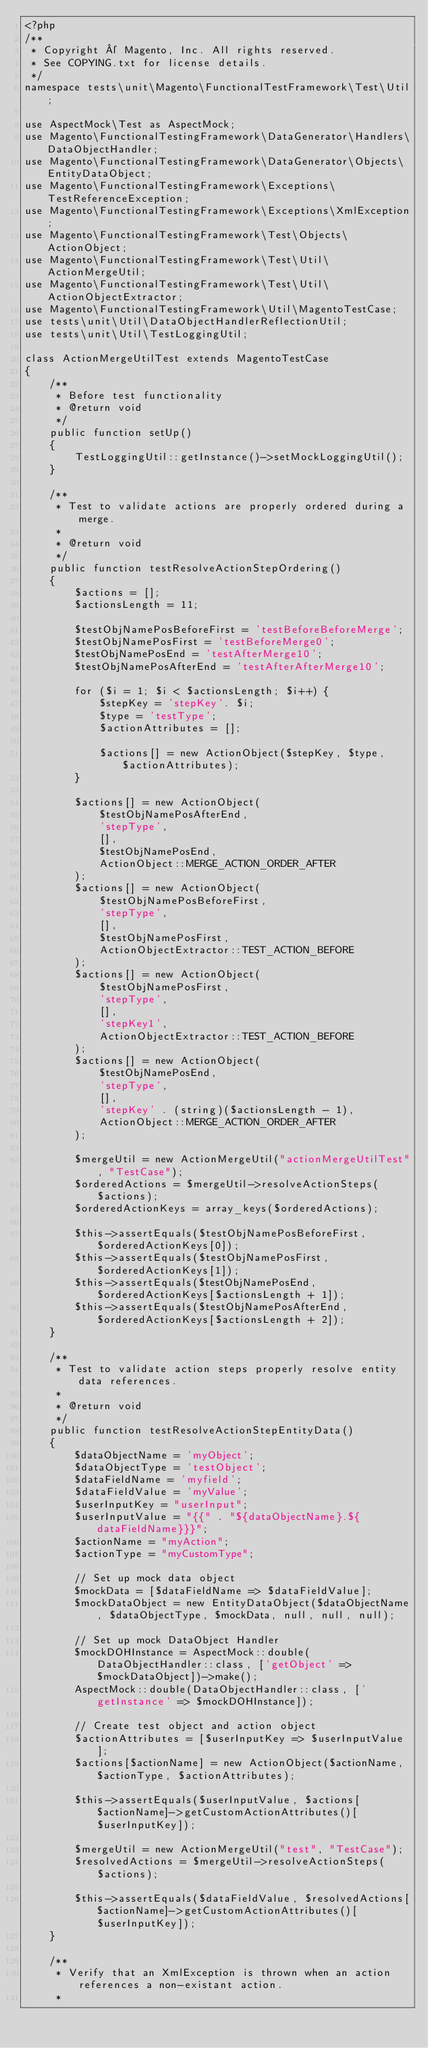<code> <loc_0><loc_0><loc_500><loc_500><_PHP_><?php
/**
 * Copyright © Magento, Inc. All rights reserved.
 * See COPYING.txt for license details.
 */
namespace tests\unit\Magento\FunctionalTestFramework\Test\Util;

use AspectMock\Test as AspectMock;
use Magento\FunctionalTestingFramework\DataGenerator\Handlers\DataObjectHandler;
use Magento\FunctionalTestingFramework\DataGenerator\Objects\EntityDataObject;
use Magento\FunctionalTestingFramework\Exceptions\TestReferenceException;
use Magento\FunctionalTestingFramework\Exceptions\XmlException;
use Magento\FunctionalTestingFramework\Test\Objects\ActionObject;
use Magento\FunctionalTestingFramework\Test\Util\ActionMergeUtil;
use Magento\FunctionalTestingFramework\Test\Util\ActionObjectExtractor;
use Magento\FunctionalTestingFramework\Util\MagentoTestCase;
use tests\unit\Util\DataObjectHandlerReflectionUtil;
use tests\unit\Util\TestLoggingUtil;

class ActionMergeUtilTest extends MagentoTestCase
{
    /**
     * Before test functionality
     * @return void
     */
    public function setUp()
    {
        TestLoggingUtil::getInstance()->setMockLoggingUtil();
    }

    /**
     * Test to validate actions are properly ordered during a merge.
     *
     * @return void
     */
    public function testResolveActionStepOrdering()
    {
        $actions = [];
        $actionsLength = 11;

        $testObjNamePosBeforeFirst = 'testBeforeBeforeMerge';
        $testObjNamePosFirst = 'testBeforeMerge0';
        $testObjNamePosEnd = 'testAfterMerge10';
        $testObjNamePosAfterEnd = 'testAfterAfterMerge10';

        for ($i = 1; $i < $actionsLength; $i++) {
            $stepKey = 'stepKey'. $i;
            $type = 'testType';
            $actionAttributes = [];

            $actions[] = new ActionObject($stepKey, $type, $actionAttributes);
        }

        $actions[] = new ActionObject(
            $testObjNamePosAfterEnd,
            'stepType',
            [],
            $testObjNamePosEnd,
            ActionObject::MERGE_ACTION_ORDER_AFTER
        );
        $actions[] = new ActionObject(
            $testObjNamePosBeforeFirst,
            'stepType',
            [],
            $testObjNamePosFirst,
            ActionObjectExtractor::TEST_ACTION_BEFORE
        );
        $actions[] = new ActionObject(
            $testObjNamePosFirst,
            'stepType',
            [],
            'stepKey1',
            ActionObjectExtractor::TEST_ACTION_BEFORE
        );
        $actions[] = new ActionObject(
            $testObjNamePosEnd,
            'stepType',
            [],
            'stepKey' . (string)($actionsLength - 1),
            ActionObject::MERGE_ACTION_ORDER_AFTER
        );

        $mergeUtil = new ActionMergeUtil("actionMergeUtilTest", "TestCase");
        $orderedActions = $mergeUtil->resolveActionSteps($actions);
        $orderedActionKeys = array_keys($orderedActions);

        $this->assertEquals($testObjNamePosBeforeFirst, $orderedActionKeys[0]);
        $this->assertEquals($testObjNamePosFirst, $orderedActionKeys[1]);
        $this->assertEquals($testObjNamePosEnd, $orderedActionKeys[$actionsLength + 1]);
        $this->assertEquals($testObjNamePosAfterEnd, $orderedActionKeys[$actionsLength + 2]);
    }

    /**
     * Test to validate action steps properly resolve entity data references.
     *
     * @return void
     */
    public function testResolveActionStepEntityData()
    {
        $dataObjectName = 'myObject';
        $dataObjectType = 'testObject';
        $dataFieldName = 'myfield';
        $dataFieldValue = 'myValue';
        $userInputKey = "userInput";
        $userInputValue = "{{" . "${dataObjectName}.${dataFieldName}}}";
        $actionName = "myAction";
        $actionType = "myCustomType";

        // Set up mock data object
        $mockData = [$dataFieldName => $dataFieldValue];
        $mockDataObject = new EntityDataObject($dataObjectName, $dataObjectType, $mockData, null, null, null);

        // Set up mock DataObject Handler
        $mockDOHInstance = AspectMock::double(DataObjectHandler::class, ['getObject' => $mockDataObject])->make();
        AspectMock::double(DataObjectHandler::class, ['getInstance' => $mockDOHInstance]);

        // Create test object and action object
        $actionAttributes = [$userInputKey => $userInputValue];
        $actions[$actionName] = new ActionObject($actionName, $actionType, $actionAttributes);

        $this->assertEquals($userInputValue, $actions[$actionName]->getCustomActionAttributes()[$userInputKey]);

        $mergeUtil = new ActionMergeUtil("test", "TestCase");
        $resolvedActions = $mergeUtil->resolveActionSteps($actions);

        $this->assertEquals($dataFieldValue, $resolvedActions[$actionName]->getCustomActionAttributes()[$userInputKey]);
    }

    /**
     * Verify that an XmlException is thrown when an action references a non-existant action.
     *</code> 